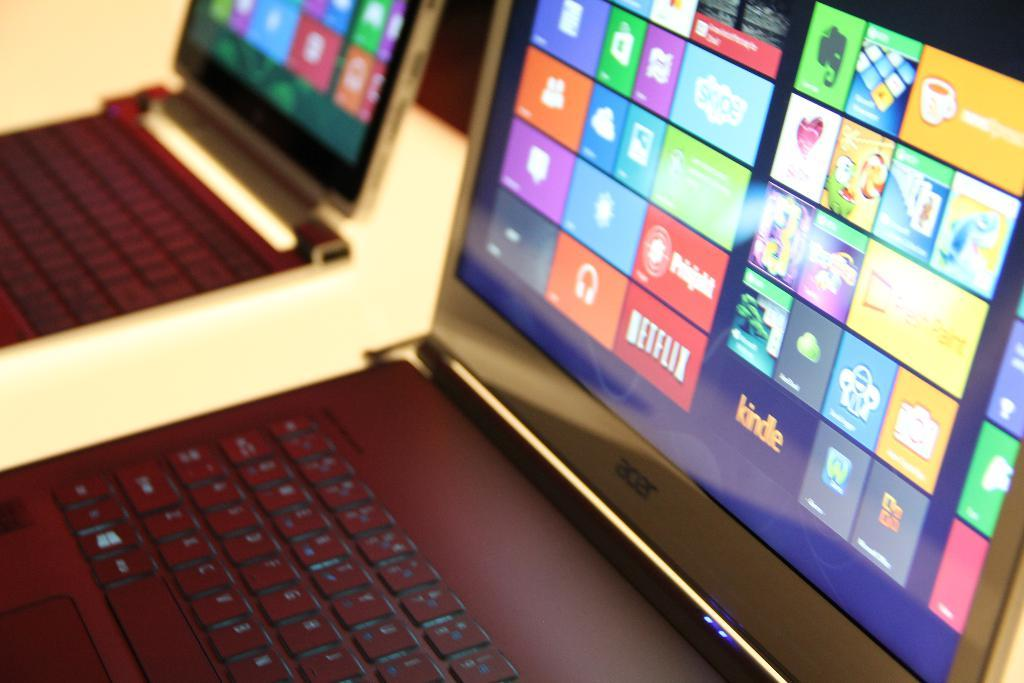Provide a one-sentence caption for the provided image. Netflix is shown in red on the icons shown on the screen. 